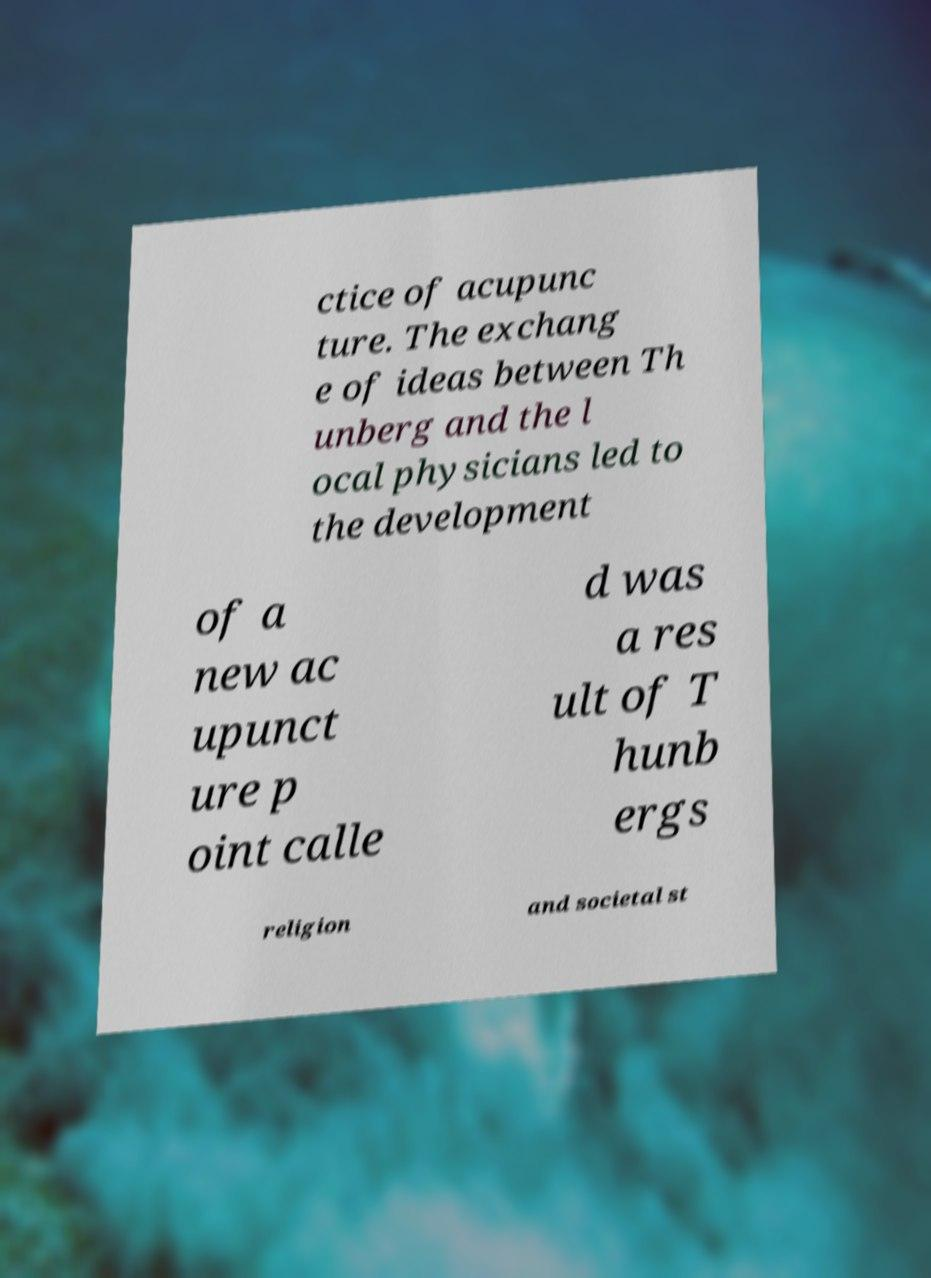Please read and relay the text visible in this image. What does it say? ctice of acupunc ture. The exchang e of ideas between Th unberg and the l ocal physicians led to the development of a new ac upunct ure p oint calle d was a res ult of T hunb ergs religion and societal st 